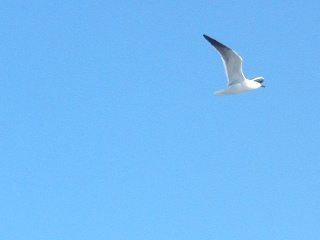In which part of the image is the bird? The bird is located in the right part of the image, gracefully gliding through the sky. 